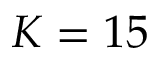Convert formula to latex. <formula><loc_0><loc_0><loc_500><loc_500>K = 1 5</formula> 